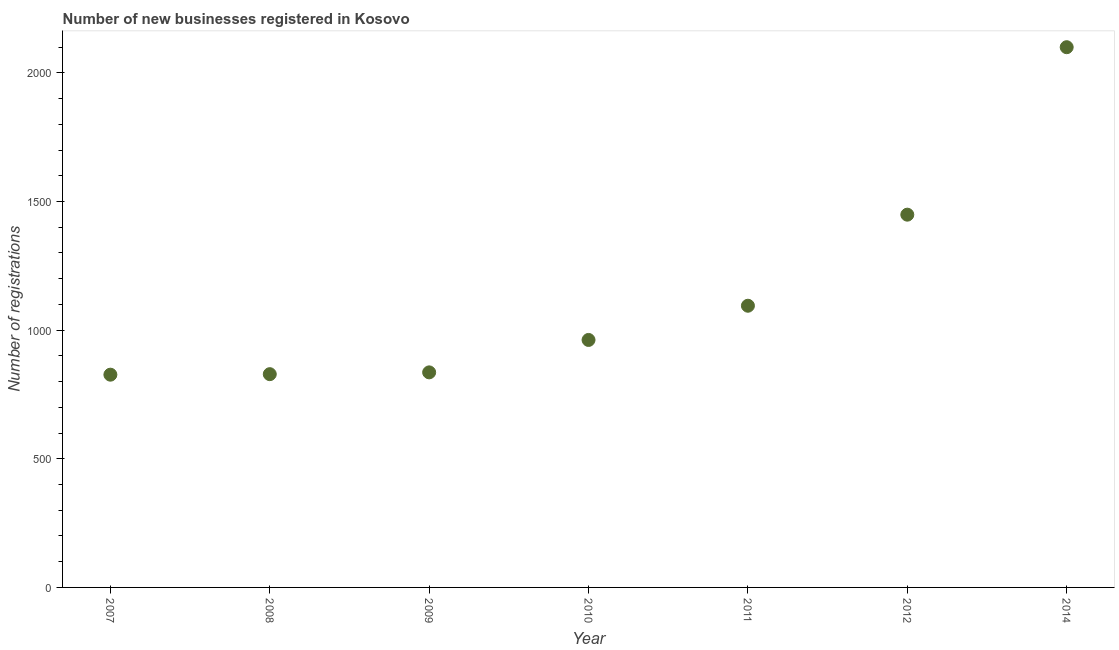What is the number of new business registrations in 2014?
Keep it short and to the point. 2100. Across all years, what is the maximum number of new business registrations?
Give a very brief answer. 2100. Across all years, what is the minimum number of new business registrations?
Offer a terse response. 827. In which year was the number of new business registrations minimum?
Ensure brevity in your answer.  2007. What is the sum of the number of new business registrations?
Keep it short and to the point. 8098. What is the difference between the number of new business registrations in 2010 and 2011?
Your answer should be compact. -133. What is the average number of new business registrations per year?
Give a very brief answer. 1156.86. What is the median number of new business registrations?
Provide a succinct answer. 962. Do a majority of the years between 2011 and 2008 (inclusive) have number of new business registrations greater than 1000 ?
Provide a succinct answer. Yes. What is the ratio of the number of new business registrations in 2007 to that in 2012?
Offer a very short reply. 0.57. Is the number of new business registrations in 2010 less than that in 2011?
Give a very brief answer. Yes. Is the difference between the number of new business registrations in 2008 and 2010 greater than the difference between any two years?
Give a very brief answer. No. What is the difference between the highest and the second highest number of new business registrations?
Your answer should be very brief. 651. Is the sum of the number of new business registrations in 2009 and 2010 greater than the maximum number of new business registrations across all years?
Provide a succinct answer. No. What is the difference between the highest and the lowest number of new business registrations?
Your answer should be compact. 1273. Are the values on the major ticks of Y-axis written in scientific E-notation?
Your response must be concise. No. Does the graph contain any zero values?
Your answer should be very brief. No. What is the title of the graph?
Provide a short and direct response. Number of new businesses registered in Kosovo. What is the label or title of the X-axis?
Provide a succinct answer. Year. What is the label or title of the Y-axis?
Provide a short and direct response. Number of registrations. What is the Number of registrations in 2007?
Give a very brief answer. 827. What is the Number of registrations in 2008?
Offer a very short reply. 829. What is the Number of registrations in 2009?
Make the answer very short. 836. What is the Number of registrations in 2010?
Provide a succinct answer. 962. What is the Number of registrations in 2011?
Your answer should be very brief. 1095. What is the Number of registrations in 2012?
Make the answer very short. 1449. What is the Number of registrations in 2014?
Make the answer very short. 2100. What is the difference between the Number of registrations in 2007 and 2008?
Ensure brevity in your answer.  -2. What is the difference between the Number of registrations in 2007 and 2010?
Your answer should be very brief. -135. What is the difference between the Number of registrations in 2007 and 2011?
Make the answer very short. -268. What is the difference between the Number of registrations in 2007 and 2012?
Make the answer very short. -622. What is the difference between the Number of registrations in 2007 and 2014?
Give a very brief answer. -1273. What is the difference between the Number of registrations in 2008 and 2009?
Offer a very short reply. -7. What is the difference between the Number of registrations in 2008 and 2010?
Provide a succinct answer. -133. What is the difference between the Number of registrations in 2008 and 2011?
Offer a very short reply. -266. What is the difference between the Number of registrations in 2008 and 2012?
Your answer should be compact. -620. What is the difference between the Number of registrations in 2008 and 2014?
Your answer should be compact. -1271. What is the difference between the Number of registrations in 2009 and 2010?
Provide a short and direct response. -126. What is the difference between the Number of registrations in 2009 and 2011?
Your response must be concise. -259. What is the difference between the Number of registrations in 2009 and 2012?
Provide a succinct answer. -613. What is the difference between the Number of registrations in 2009 and 2014?
Keep it short and to the point. -1264. What is the difference between the Number of registrations in 2010 and 2011?
Provide a short and direct response. -133. What is the difference between the Number of registrations in 2010 and 2012?
Your response must be concise. -487. What is the difference between the Number of registrations in 2010 and 2014?
Your response must be concise. -1138. What is the difference between the Number of registrations in 2011 and 2012?
Your response must be concise. -354. What is the difference between the Number of registrations in 2011 and 2014?
Give a very brief answer. -1005. What is the difference between the Number of registrations in 2012 and 2014?
Give a very brief answer. -651. What is the ratio of the Number of registrations in 2007 to that in 2010?
Make the answer very short. 0.86. What is the ratio of the Number of registrations in 2007 to that in 2011?
Ensure brevity in your answer.  0.76. What is the ratio of the Number of registrations in 2007 to that in 2012?
Offer a very short reply. 0.57. What is the ratio of the Number of registrations in 2007 to that in 2014?
Provide a short and direct response. 0.39. What is the ratio of the Number of registrations in 2008 to that in 2010?
Offer a terse response. 0.86. What is the ratio of the Number of registrations in 2008 to that in 2011?
Provide a short and direct response. 0.76. What is the ratio of the Number of registrations in 2008 to that in 2012?
Provide a short and direct response. 0.57. What is the ratio of the Number of registrations in 2008 to that in 2014?
Make the answer very short. 0.4. What is the ratio of the Number of registrations in 2009 to that in 2010?
Offer a very short reply. 0.87. What is the ratio of the Number of registrations in 2009 to that in 2011?
Offer a very short reply. 0.76. What is the ratio of the Number of registrations in 2009 to that in 2012?
Provide a succinct answer. 0.58. What is the ratio of the Number of registrations in 2009 to that in 2014?
Give a very brief answer. 0.4. What is the ratio of the Number of registrations in 2010 to that in 2011?
Make the answer very short. 0.88. What is the ratio of the Number of registrations in 2010 to that in 2012?
Give a very brief answer. 0.66. What is the ratio of the Number of registrations in 2010 to that in 2014?
Ensure brevity in your answer.  0.46. What is the ratio of the Number of registrations in 2011 to that in 2012?
Ensure brevity in your answer.  0.76. What is the ratio of the Number of registrations in 2011 to that in 2014?
Give a very brief answer. 0.52. What is the ratio of the Number of registrations in 2012 to that in 2014?
Provide a succinct answer. 0.69. 